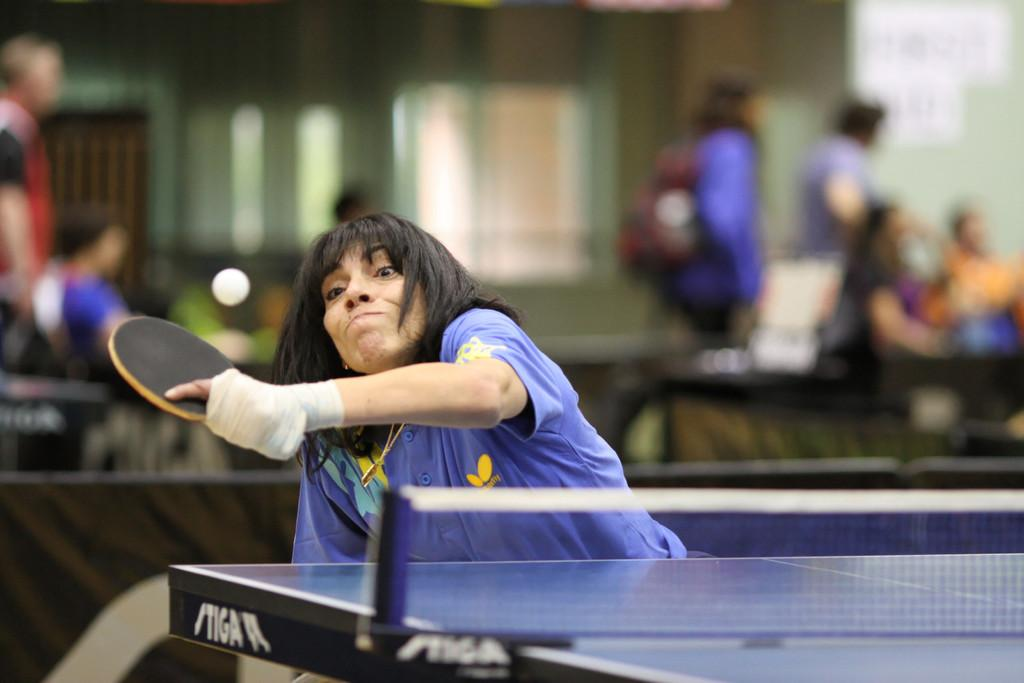Who is present in the image? There is a woman in the image. What is the woman holding in her hand? The woman is holding a bat in her hand. Can you describe the woman's ability to fly in the image? There is no indication in the image that the woman is flying or has any special abilities. 